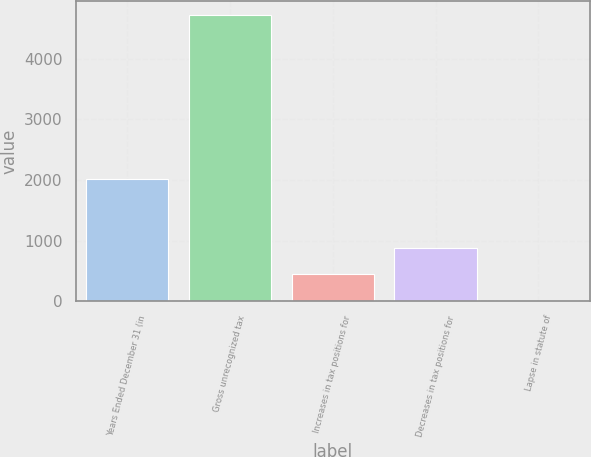Convert chart. <chart><loc_0><loc_0><loc_500><loc_500><bar_chart><fcel>Years Ended December 31 (in<fcel>Gross unrecognized tax<fcel>Increases in tax positions for<fcel>Decreases in tax positions for<fcel>Lapse in statute of<nl><fcel>2012<fcel>4716.7<fcel>445.7<fcel>883.4<fcel>8<nl></chart> 